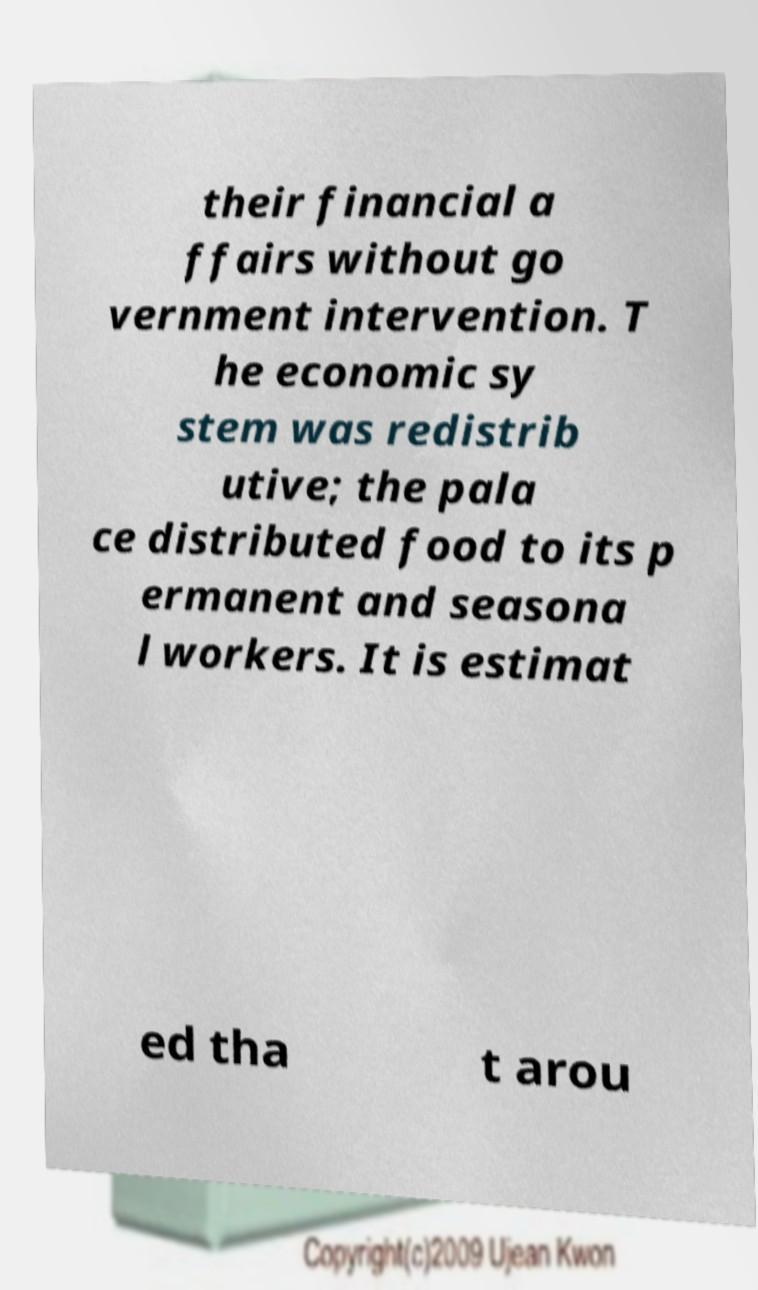What messages or text are displayed in this image? I need them in a readable, typed format. their financial a ffairs without go vernment intervention. T he economic sy stem was redistrib utive; the pala ce distributed food to its p ermanent and seasona l workers. It is estimat ed tha t arou 